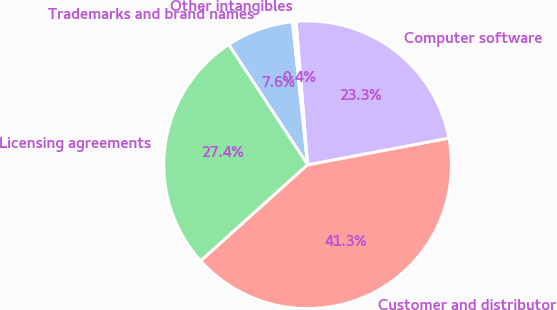Convert chart. <chart><loc_0><loc_0><loc_500><loc_500><pie_chart><fcel>Trademarks and brand names<fcel>Licensing agreements<fcel>Customer and distributor<fcel>Computer software<fcel>Other intangibles<nl><fcel>7.56%<fcel>27.41%<fcel>41.32%<fcel>23.31%<fcel>0.4%<nl></chart> 